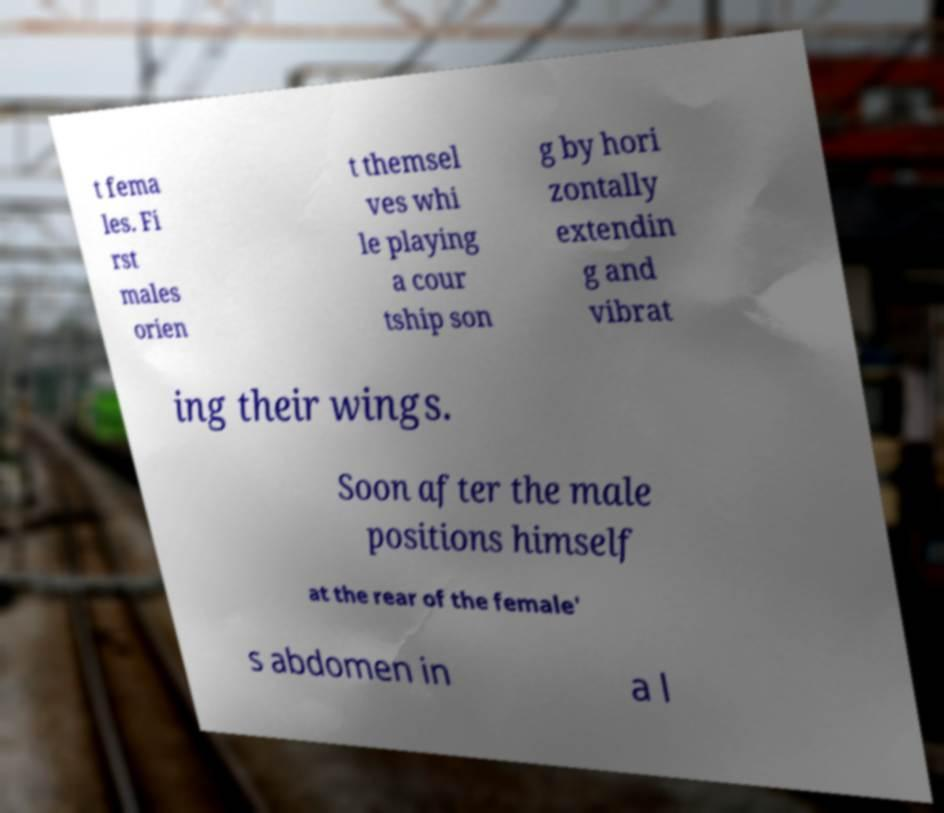Please identify and transcribe the text found in this image. t fema les. Fi rst males orien t themsel ves whi le playing a cour tship son g by hori zontally extendin g and vibrat ing their wings. Soon after the male positions himself at the rear of the female' s abdomen in a l 